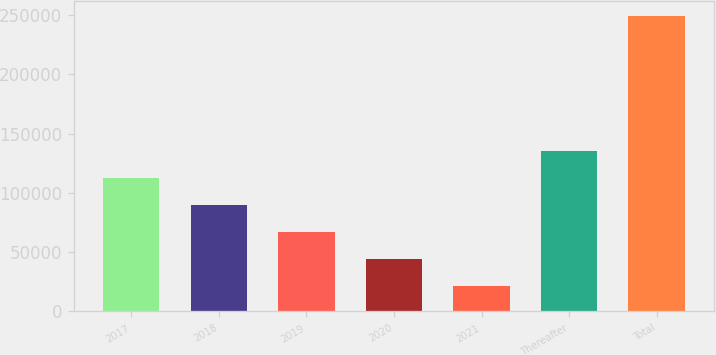Convert chart to OTSL. <chart><loc_0><loc_0><loc_500><loc_500><bar_chart><fcel>2017<fcel>2018<fcel>2019<fcel>2020<fcel>2021<fcel>Thereafter<fcel>Total<nl><fcel>112577<fcel>89760.6<fcel>66944.4<fcel>44128.2<fcel>21312<fcel>135393<fcel>249474<nl></chart> 